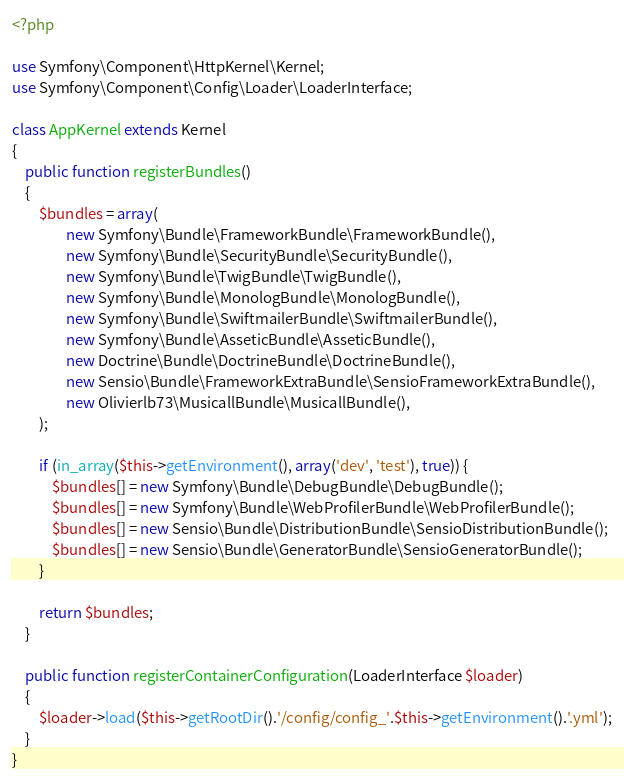Convert code to text. <code><loc_0><loc_0><loc_500><loc_500><_PHP_><?php

use Symfony\Component\HttpKernel\Kernel;
use Symfony\Component\Config\Loader\LoaderInterface;

class AppKernel extends Kernel
{
	public function registerBundles()
	{
		$bundles = array(
				new Symfony\Bundle\FrameworkBundle\FrameworkBundle(),
				new Symfony\Bundle\SecurityBundle\SecurityBundle(),
				new Symfony\Bundle\TwigBundle\TwigBundle(),
				new Symfony\Bundle\MonologBundle\MonologBundle(),
				new Symfony\Bundle\SwiftmailerBundle\SwiftmailerBundle(),
				new Symfony\Bundle\AsseticBundle\AsseticBundle(),
				new Doctrine\Bundle\DoctrineBundle\DoctrineBundle(),
				new Sensio\Bundle\FrameworkExtraBundle\SensioFrameworkExtraBundle(),
				new Olivierlb73\MusicallBundle\MusicallBundle(),
		);

		if (in_array($this->getEnvironment(), array('dev', 'test'), true)) {
			$bundles[] = new Symfony\Bundle\DebugBundle\DebugBundle();
			$bundles[] = new Symfony\Bundle\WebProfilerBundle\WebProfilerBundle();
			$bundles[] = new Sensio\Bundle\DistributionBundle\SensioDistributionBundle();
			$bundles[] = new Sensio\Bundle\GeneratorBundle\SensioGeneratorBundle();
		}

		return $bundles;
	}

	public function registerContainerConfiguration(LoaderInterface $loader)
	{
		$loader->load($this->getRootDir().'/config/config_'.$this->getEnvironment().'.yml');
	}
}
</code> 